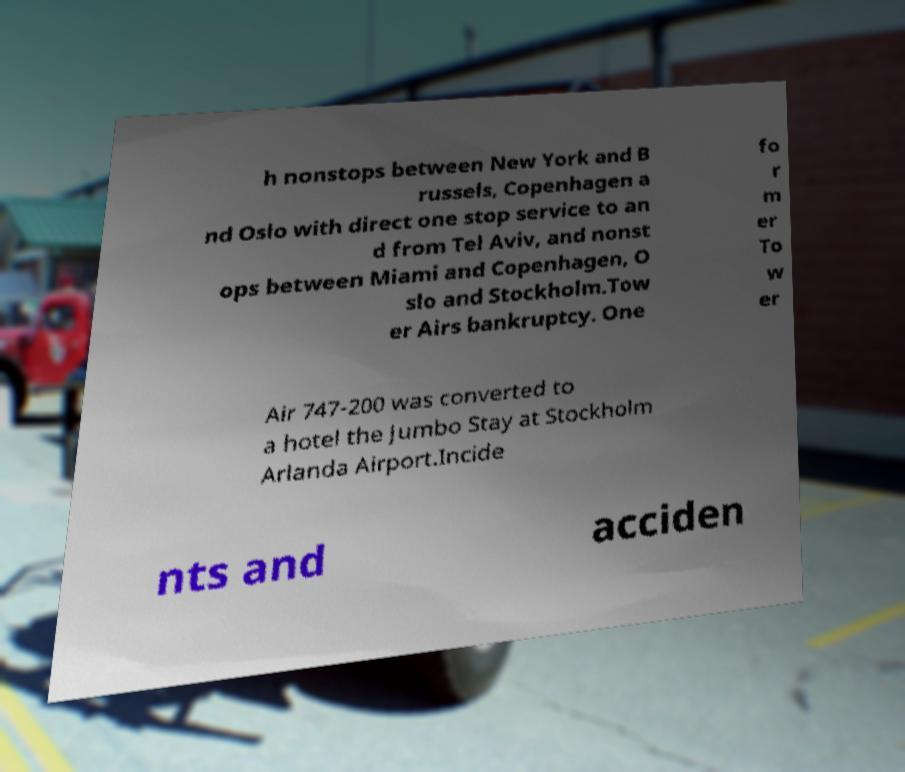Could you assist in decoding the text presented in this image and type it out clearly? h nonstops between New York and B russels, Copenhagen a nd Oslo with direct one stop service to an d from Tel Aviv, and nonst ops between Miami and Copenhagen, O slo and Stockholm.Tow er Airs bankruptcy. One fo r m er To w er Air 747-200 was converted to a hotel the Jumbo Stay at Stockholm Arlanda Airport.Incide nts and acciden 